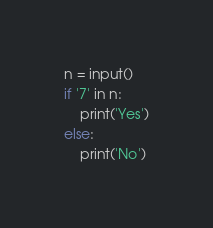Convert code to text. <code><loc_0><loc_0><loc_500><loc_500><_Python_>n = input()
if '7' in n:
    print('Yes')
else:
    print('No')</code> 